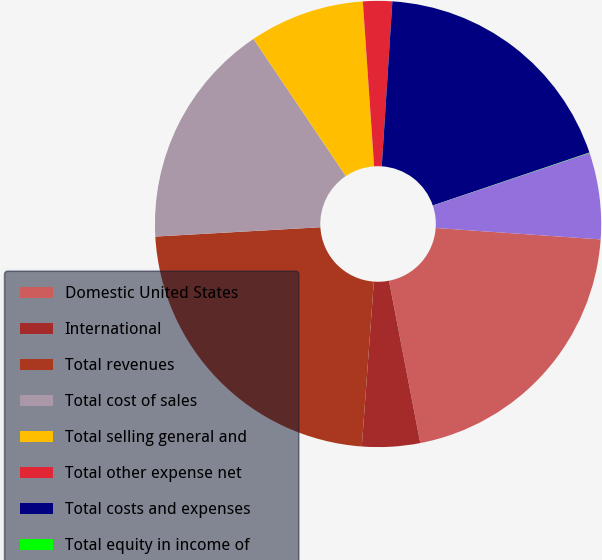<chart> <loc_0><loc_0><loc_500><loc_500><pie_chart><fcel>Domestic United States<fcel>International<fcel>Total revenues<fcel>Total cost of sales<fcel>Total selling general and<fcel>Total other expense net<fcel>Total costs and expenses<fcel>Total equity in income of<fcel>Income before income taxes<nl><fcel>20.87%<fcel>4.19%<fcel>22.94%<fcel>16.47%<fcel>8.34%<fcel>2.11%<fcel>18.79%<fcel>0.03%<fcel>6.26%<nl></chart> 